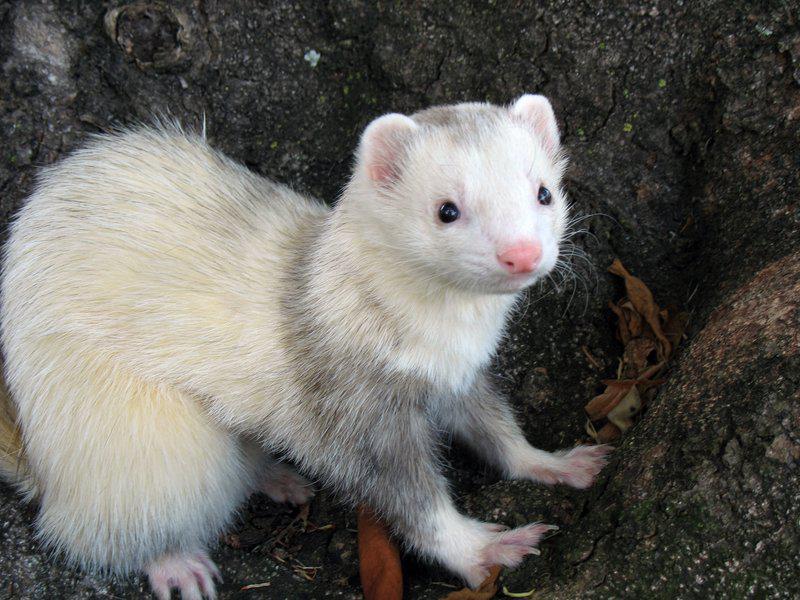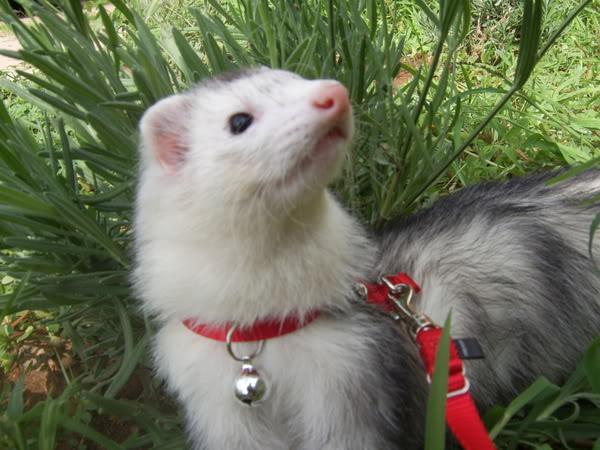The first image is the image on the left, the second image is the image on the right. Examine the images to the left and right. Is the description "Each image shows a single forward-turned ferret, and at least one ferret has solid-white fur." accurate? Answer yes or no. No. The first image is the image on the left, the second image is the image on the right. Examine the images to the left and right. Is the description "One ferret is on a rock." accurate? Answer yes or no. Yes. 